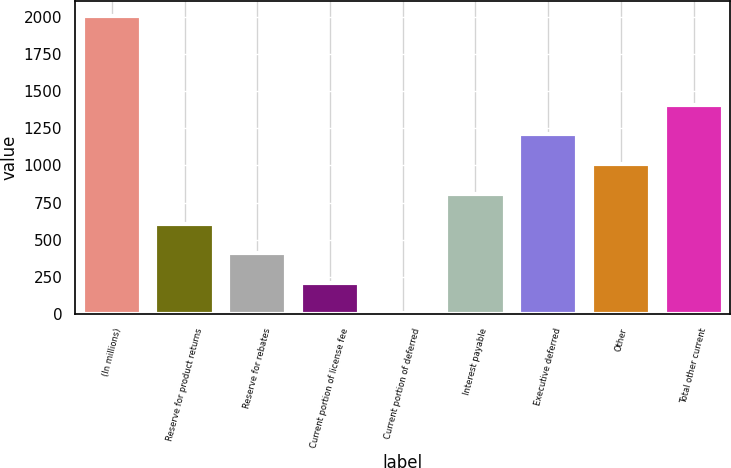<chart> <loc_0><loc_0><loc_500><loc_500><bar_chart><fcel>(In millions)<fcel>Reserve for product returns<fcel>Reserve for rebates<fcel>Current portion of license fee<fcel>Current portion of deferred<fcel>Interest payable<fcel>Executive deferred<fcel>Other<fcel>Total other current<nl><fcel>2010<fcel>607.9<fcel>407.6<fcel>207.3<fcel>7<fcel>808.2<fcel>1208.8<fcel>1008.5<fcel>1409.1<nl></chart> 